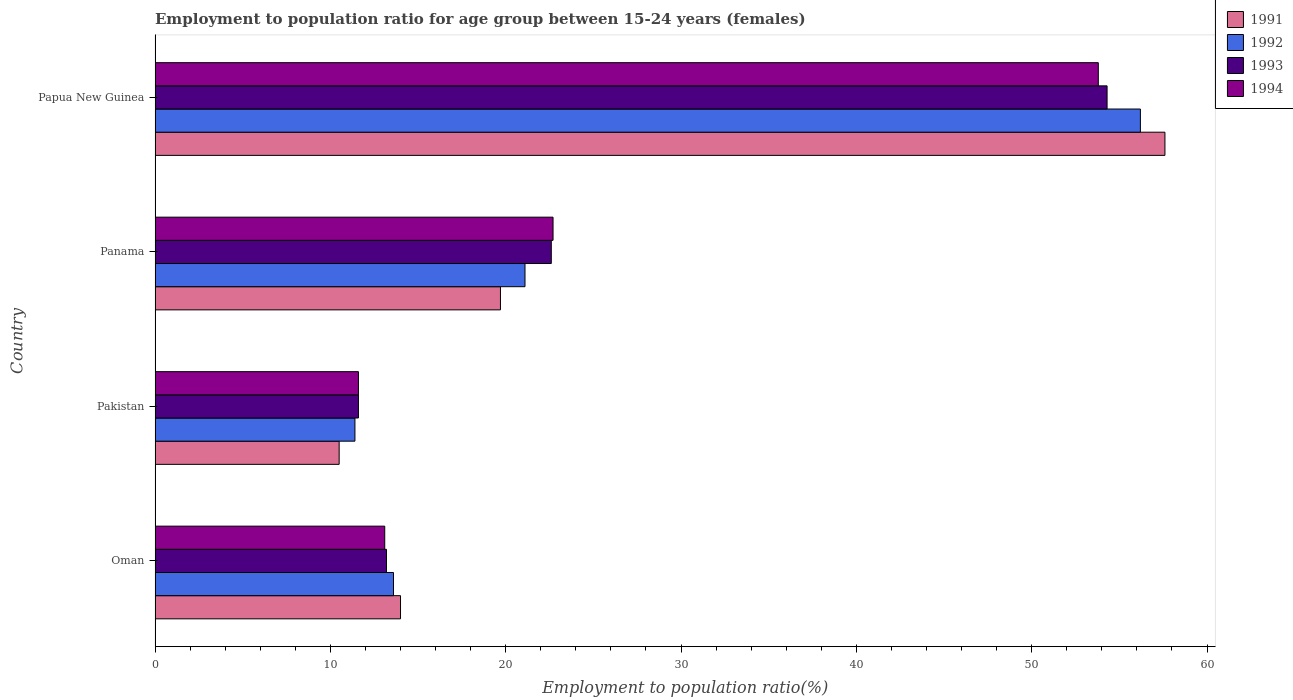How many groups of bars are there?
Keep it short and to the point. 4. Are the number of bars per tick equal to the number of legend labels?
Make the answer very short. Yes. What is the label of the 4th group of bars from the top?
Make the answer very short. Oman. What is the employment to population ratio in 1993 in Panama?
Provide a succinct answer. 22.6. Across all countries, what is the maximum employment to population ratio in 1994?
Your response must be concise. 53.8. Across all countries, what is the minimum employment to population ratio in 1992?
Offer a very short reply. 11.4. In which country was the employment to population ratio in 1993 maximum?
Your response must be concise. Papua New Guinea. In which country was the employment to population ratio in 1993 minimum?
Keep it short and to the point. Pakistan. What is the total employment to population ratio in 1992 in the graph?
Offer a very short reply. 102.3. What is the difference between the employment to population ratio in 1993 in Oman and that in Papua New Guinea?
Give a very brief answer. -41.1. What is the difference between the employment to population ratio in 1991 in Oman and the employment to population ratio in 1992 in Pakistan?
Provide a succinct answer. 2.6. What is the average employment to population ratio in 1994 per country?
Make the answer very short. 25.3. What is the difference between the employment to population ratio in 1991 and employment to population ratio in 1993 in Oman?
Provide a succinct answer. 0.8. What is the ratio of the employment to population ratio in 1991 in Oman to that in Panama?
Provide a succinct answer. 0.71. Is the difference between the employment to population ratio in 1991 in Pakistan and Panama greater than the difference between the employment to population ratio in 1993 in Pakistan and Panama?
Offer a very short reply. Yes. What is the difference between the highest and the second highest employment to population ratio in 1993?
Offer a terse response. 31.7. What is the difference between the highest and the lowest employment to population ratio in 1991?
Your response must be concise. 47.1. Is it the case that in every country, the sum of the employment to population ratio in 1991 and employment to population ratio in 1992 is greater than the sum of employment to population ratio in 1994 and employment to population ratio in 1993?
Give a very brief answer. No. Is it the case that in every country, the sum of the employment to population ratio in 1994 and employment to population ratio in 1993 is greater than the employment to population ratio in 1992?
Provide a short and direct response. Yes. Does the graph contain any zero values?
Your answer should be very brief. No. Where does the legend appear in the graph?
Your answer should be very brief. Top right. How many legend labels are there?
Your answer should be very brief. 4. How are the legend labels stacked?
Your answer should be very brief. Vertical. What is the title of the graph?
Ensure brevity in your answer.  Employment to population ratio for age group between 15-24 years (females). Does "1968" appear as one of the legend labels in the graph?
Provide a succinct answer. No. What is the Employment to population ratio(%) in 1991 in Oman?
Give a very brief answer. 14. What is the Employment to population ratio(%) of 1992 in Oman?
Provide a short and direct response. 13.6. What is the Employment to population ratio(%) of 1993 in Oman?
Give a very brief answer. 13.2. What is the Employment to population ratio(%) in 1994 in Oman?
Provide a succinct answer. 13.1. What is the Employment to population ratio(%) in 1992 in Pakistan?
Your response must be concise. 11.4. What is the Employment to population ratio(%) in 1993 in Pakistan?
Keep it short and to the point. 11.6. What is the Employment to population ratio(%) of 1994 in Pakistan?
Give a very brief answer. 11.6. What is the Employment to population ratio(%) of 1991 in Panama?
Your response must be concise. 19.7. What is the Employment to population ratio(%) in 1992 in Panama?
Your answer should be compact. 21.1. What is the Employment to population ratio(%) of 1993 in Panama?
Provide a short and direct response. 22.6. What is the Employment to population ratio(%) of 1994 in Panama?
Offer a very short reply. 22.7. What is the Employment to population ratio(%) in 1991 in Papua New Guinea?
Ensure brevity in your answer.  57.6. What is the Employment to population ratio(%) in 1992 in Papua New Guinea?
Keep it short and to the point. 56.2. What is the Employment to population ratio(%) of 1993 in Papua New Guinea?
Offer a very short reply. 54.3. What is the Employment to population ratio(%) of 1994 in Papua New Guinea?
Offer a terse response. 53.8. Across all countries, what is the maximum Employment to population ratio(%) in 1991?
Provide a short and direct response. 57.6. Across all countries, what is the maximum Employment to population ratio(%) in 1992?
Provide a short and direct response. 56.2. Across all countries, what is the maximum Employment to population ratio(%) of 1993?
Ensure brevity in your answer.  54.3. Across all countries, what is the maximum Employment to population ratio(%) in 1994?
Offer a very short reply. 53.8. Across all countries, what is the minimum Employment to population ratio(%) in 1992?
Your answer should be compact. 11.4. Across all countries, what is the minimum Employment to population ratio(%) in 1993?
Make the answer very short. 11.6. Across all countries, what is the minimum Employment to population ratio(%) in 1994?
Make the answer very short. 11.6. What is the total Employment to population ratio(%) in 1991 in the graph?
Provide a succinct answer. 101.8. What is the total Employment to population ratio(%) of 1992 in the graph?
Provide a short and direct response. 102.3. What is the total Employment to population ratio(%) of 1993 in the graph?
Keep it short and to the point. 101.7. What is the total Employment to population ratio(%) of 1994 in the graph?
Provide a succinct answer. 101.2. What is the difference between the Employment to population ratio(%) of 1994 in Oman and that in Pakistan?
Your answer should be very brief. 1.5. What is the difference between the Employment to population ratio(%) of 1994 in Oman and that in Panama?
Provide a succinct answer. -9.6. What is the difference between the Employment to population ratio(%) in 1991 in Oman and that in Papua New Guinea?
Make the answer very short. -43.6. What is the difference between the Employment to population ratio(%) of 1992 in Oman and that in Papua New Guinea?
Give a very brief answer. -42.6. What is the difference between the Employment to population ratio(%) in 1993 in Oman and that in Papua New Guinea?
Keep it short and to the point. -41.1. What is the difference between the Employment to population ratio(%) of 1994 in Oman and that in Papua New Guinea?
Your answer should be very brief. -40.7. What is the difference between the Employment to population ratio(%) in 1992 in Pakistan and that in Panama?
Your answer should be compact. -9.7. What is the difference between the Employment to population ratio(%) in 1993 in Pakistan and that in Panama?
Your answer should be compact. -11. What is the difference between the Employment to population ratio(%) of 1991 in Pakistan and that in Papua New Guinea?
Your answer should be very brief. -47.1. What is the difference between the Employment to population ratio(%) in 1992 in Pakistan and that in Papua New Guinea?
Offer a terse response. -44.8. What is the difference between the Employment to population ratio(%) in 1993 in Pakistan and that in Papua New Guinea?
Make the answer very short. -42.7. What is the difference between the Employment to population ratio(%) of 1994 in Pakistan and that in Papua New Guinea?
Provide a succinct answer. -42.2. What is the difference between the Employment to population ratio(%) in 1991 in Panama and that in Papua New Guinea?
Your answer should be very brief. -37.9. What is the difference between the Employment to population ratio(%) of 1992 in Panama and that in Papua New Guinea?
Your response must be concise. -35.1. What is the difference between the Employment to population ratio(%) in 1993 in Panama and that in Papua New Guinea?
Make the answer very short. -31.7. What is the difference between the Employment to population ratio(%) in 1994 in Panama and that in Papua New Guinea?
Keep it short and to the point. -31.1. What is the difference between the Employment to population ratio(%) of 1991 in Oman and the Employment to population ratio(%) of 1994 in Pakistan?
Your answer should be compact. 2.4. What is the difference between the Employment to population ratio(%) of 1992 in Oman and the Employment to population ratio(%) of 1993 in Pakistan?
Make the answer very short. 2. What is the difference between the Employment to population ratio(%) of 1991 in Oman and the Employment to population ratio(%) of 1993 in Panama?
Make the answer very short. -8.6. What is the difference between the Employment to population ratio(%) in 1992 in Oman and the Employment to population ratio(%) in 1993 in Panama?
Give a very brief answer. -9. What is the difference between the Employment to population ratio(%) in 1993 in Oman and the Employment to population ratio(%) in 1994 in Panama?
Offer a very short reply. -9.5. What is the difference between the Employment to population ratio(%) of 1991 in Oman and the Employment to population ratio(%) of 1992 in Papua New Guinea?
Give a very brief answer. -42.2. What is the difference between the Employment to population ratio(%) in 1991 in Oman and the Employment to population ratio(%) in 1993 in Papua New Guinea?
Your answer should be compact. -40.3. What is the difference between the Employment to population ratio(%) of 1991 in Oman and the Employment to population ratio(%) of 1994 in Papua New Guinea?
Ensure brevity in your answer.  -39.8. What is the difference between the Employment to population ratio(%) in 1992 in Oman and the Employment to population ratio(%) in 1993 in Papua New Guinea?
Offer a terse response. -40.7. What is the difference between the Employment to population ratio(%) in 1992 in Oman and the Employment to population ratio(%) in 1994 in Papua New Guinea?
Your answer should be very brief. -40.2. What is the difference between the Employment to population ratio(%) in 1993 in Oman and the Employment to population ratio(%) in 1994 in Papua New Guinea?
Keep it short and to the point. -40.6. What is the difference between the Employment to population ratio(%) in 1991 in Pakistan and the Employment to population ratio(%) in 1992 in Panama?
Ensure brevity in your answer.  -10.6. What is the difference between the Employment to population ratio(%) of 1992 in Pakistan and the Employment to population ratio(%) of 1994 in Panama?
Offer a very short reply. -11.3. What is the difference between the Employment to population ratio(%) of 1993 in Pakistan and the Employment to population ratio(%) of 1994 in Panama?
Offer a very short reply. -11.1. What is the difference between the Employment to population ratio(%) of 1991 in Pakistan and the Employment to population ratio(%) of 1992 in Papua New Guinea?
Provide a succinct answer. -45.7. What is the difference between the Employment to population ratio(%) of 1991 in Pakistan and the Employment to population ratio(%) of 1993 in Papua New Guinea?
Your response must be concise. -43.8. What is the difference between the Employment to population ratio(%) of 1991 in Pakistan and the Employment to population ratio(%) of 1994 in Papua New Guinea?
Your response must be concise. -43.3. What is the difference between the Employment to population ratio(%) of 1992 in Pakistan and the Employment to population ratio(%) of 1993 in Papua New Guinea?
Offer a very short reply. -42.9. What is the difference between the Employment to population ratio(%) in 1992 in Pakistan and the Employment to population ratio(%) in 1994 in Papua New Guinea?
Make the answer very short. -42.4. What is the difference between the Employment to population ratio(%) of 1993 in Pakistan and the Employment to population ratio(%) of 1994 in Papua New Guinea?
Make the answer very short. -42.2. What is the difference between the Employment to population ratio(%) in 1991 in Panama and the Employment to population ratio(%) in 1992 in Papua New Guinea?
Your response must be concise. -36.5. What is the difference between the Employment to population ratio(%) in 1991 in Panama and the Employment to population ratio(%) in 1993 in Papua New Guinea?
Your answer should be compact. -34.6. What is the difference between the Employment to population ratio(%) in 1991 in Panama and the Employment to population ratio(%) in 1994 in Papua New Guinea?
Ensure brevity in your answer.  -34.1. What is the difference between the Employment to population ratio(%) in 1992 in Panama and the Employment to population ratio(%) in 1993 in Papua New Guinea?
Offer a very short reply. -33.2. What is the difference between the Employment to population ratio(%) in 1992 in Panama and the Employment to population ratio(%) in 1994 in Papua New Guinea?
Ensure brevity in your answer.  -32.7. What is the difference between the Employment to population ratio(%) of 1993 in Panama and the Employment to population ratio(%) of 1994 in Papua New Guinea?
Your response must be concise. -31.2. What is the average Employment to population ratio(%) of 1991 per country?
Provide a short and direct response. 25.45. What is the average Employment to population ratio(%) of 1992 per country?
Your answer should be compact. 25.57. What is the average Employment to population ratio(%) in 1993 per country?
Provide a succinct answer. 25.43. What is the average Employment to population ratio(%) in 1994 per country?
Provide a short and direct response. 25.3. What is the difference between the Employment to population ratio(%) in 1991 and Employment to population ratio(%) in 1992 in Oman?
Offer a very short reply. 0.4. What is the difference between the Employment to population ratio(%) of 1991 and Employment to population ratio(%) of 1992 in Pakistan?
Offer a very short reply. -0.9. What is the difference between the Employment to population ratio(%) of 1991 and Employment to population ratio(%) of 1994 in Pakistan?
Keep it short and to the point. -1.1. What is the difference between the Employment to population ratio(%) of 1992 and Employment to population ratio(%) of 1993 in Pakistan?
Your answer should be compact. -0.2. What is the difference between the Employment to population ratio(%) of 1991 and Employment to population ratio(%) of 1993 in Panama?
Your response must be concise. -2.9. What is the difference between the Employment to population ratio(%) in 1992 and Employment to population ratio(%) in 1993 in Panama?
Keep it short and to the point. -1.5. What is the difference between the Employment to population ratio(%) of 1991 and Employment to population ratio(%) of 1992 in Papua New Guinea?
Offer a very short reply. 1.4. What is the difference between the Employment to population ratio(%) in 1991 and Employment to population ratio(%) in 1994 in Papua New Guinea?
Keep it short and to the point. 3.8. What is the difference between the Employment to population ratio(%) of 1992 and Employment to population ratio(%) of 1993 in Papua New Guinea?
Keep it short and to the point. 1.9. What is the ratio of the Employment to population ratio(%) in 1992 in Oman to that in Pakistan?
Provide a short and direct response. 1.19. What is the ratio of the Employment to population ratio(%) in 1993 in Oman to that in Pakistan?
Keep it short and to the point. 1.14. What is the ratio of the Employment to population ratio(%) in 1994 in Oman to that in Pakistan?
Make the answer very short. 1.13. What is the ratio of the Employment to population ratio(%) of 1991 in Oman to that in Panama?
Provide a succinct answer. 0.71. What is the ratio of the Employment to population ratio(%) in 1992 in Oman to that in Panama?
Your answer should be very brief. 0.64. What is the ratio of the Employment to population ratio(%) of 1993 in Oman to that in Panama?
Offer a very short reply. 0.58. What is the ratio of the Employment to population ratio(%) in 1994 in Oman to that in Panama?
Your response must be concise. 0.58. What is the ratio of the Employment to population ratio(%) in 1991 in Oman to that in Papua New Guinea?
Offer a terse response. 0.24. What is the ratio of the Employment to population ratio(%) of 1992 in Oman to that in Papua New Guinea?
Make the answer very short. 0.24. What is the ratio of the Employment to population ratio(%) in 1993 in Oman to that in Papua New Guinea?
Provide a short and direct response. 0.24. What is the ratio of the Employment to population ratio(%) in 1994 in Oman to that in Papua New Guinea?
Your response must be concise. 0.24. What is the ratio of the Employment to population ratio(%) of 1991 in Pakistan to that in Panama?
Make the answer very short. 0.53. What is the ratio of the Employment to population ratio(%) of 1992 in Pakistan to that in Panama?
Provide a short and direct response. 0.54. What is the ratio of the Employment to population ratio(%) in 1993 in Pakistan to that in Panama?
Give a very brief answer. 0.51. What is the ratio of the Employment to population ratio(%) of 1994 in Pakistan to that in Panama?
Provide a short and direct response. 0.51. What is the ratio of the Employment to population ratio(%) in 1991 in Pakistan to that in Papua New Guinea?
Provide a short and direct response. 0.18. What is the ratio of the Employment to population ratio(%) of 1992 in Pakistan to that in Papua New Guinea?
Make the answer very short. 0.2. What is the ratio of the Employment to population ratio(%) in 1993 in Pakistan to that in Papua New Guinea?
Offer a very short reply. 0.21. What is the ratio of the Employment to population ratio(%) in 1994 in Pakistan to that in Papua New Guinea?
Your answer should be very brief. 0.22. What is the ratio of the Employment to population ratio(%) of 1991 in Panama to that in Papua New Guinea?
Offer a terse response. 0.34. What is the ratio of the Employment to population ratio(%) in 1992 in Panama to that in Papua New Guinea?
Your response must be concise. 0.38. What is the ratio of the Employment to population ratio(%) of 1993 in Panama to that in Papua New Guinea?
Offer a very short reply. 0.42. What is the ratio of the Employment to population ratio(%) of 1994 in Panama to that in Papua New Guinea?
Your response must be concise. 0.42. What is the difference between the highest and the second highest Employment to population ratio(%) of 1991?
Give a very brief answer. 37.9. What is the difference between the highest and the second highest Employment to population ratio(%) of 1992?
Provide a short and direct response. 35.1. What is the difference between the highest and the second highest Employment to population ratio(%) in 1993?
Offer a terse response. 31.7. What is the difference between the highest and the second highest Employment to population ratio(%) in 1994?
Provide a succinct answer. 31.1. What is the difference between the highest and the lowest Employment to population ratio(%) in 1991?
Your response must be concise. 47.1. What is the difference between the highest and the lowest Employment to population ratio(%) in 1992?
Provide a succinct answer. 44.8. What is the difference between the highest and the lowest Employment to population ratio(%) in 1993?
Offer a terse response. 42.7. What is the difference between the highest and the lowest Employment to population ratio(%) in 1994?
Offer a terse response. 42.2. 